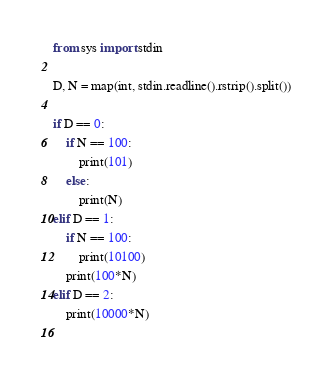<code> <loc_0><loc_0><loc_500><loc_500><_Python_>from sys import stdin

D, N = map(int, stdin.readline().rstrip().split())

if D == 0:
    if N == 100:
        print(101)
    else:
        print(N)
elif D == 1:
    if N == 100:
        print(10100)
    print(100*N)
elif D == 2:
    print(10000*N)
    
</code> 